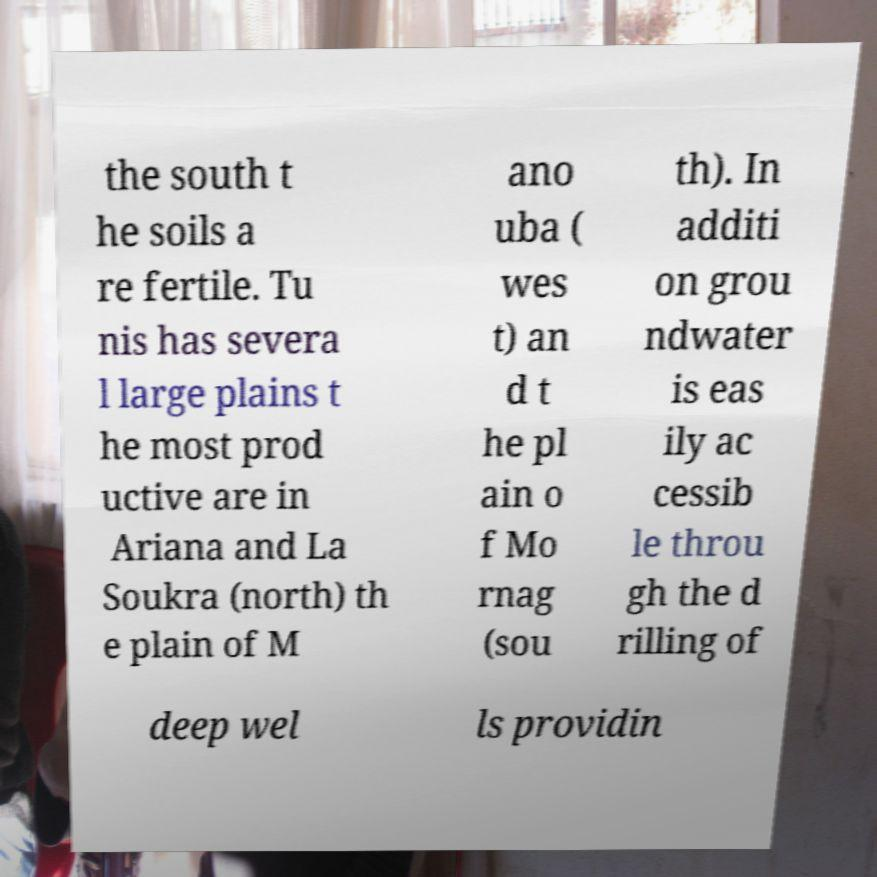Please read and relay the text visible in this image. What does it say? the south t he soils a re fertile. Tu nis has severa l large plains t he most prod uctive are in Ariana and La Soukra (north) th e plain of M ano uba ( wes t) an d t he pl ain o f Mo rnag (sou th). In additi on grou ndwater is eas ily ac cessib le throu gh the d rilling of deep wel ls providin 